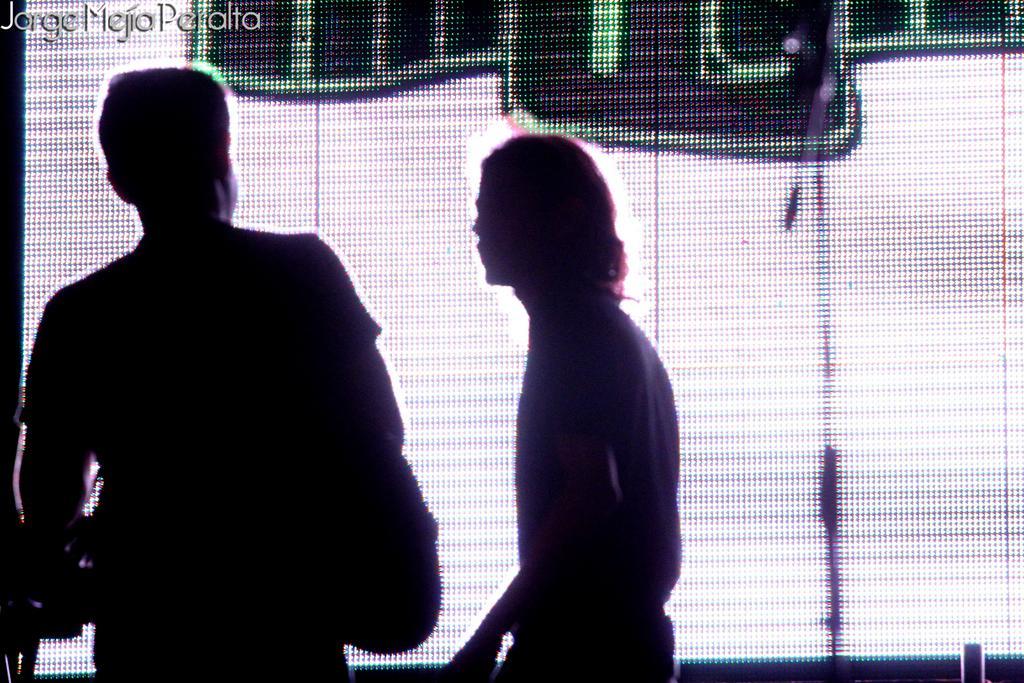How would you summarize this image in a sentence or two? In this picture I can see two persons standing and in the background there is a screen, and at the top of the image there is a watermark. 